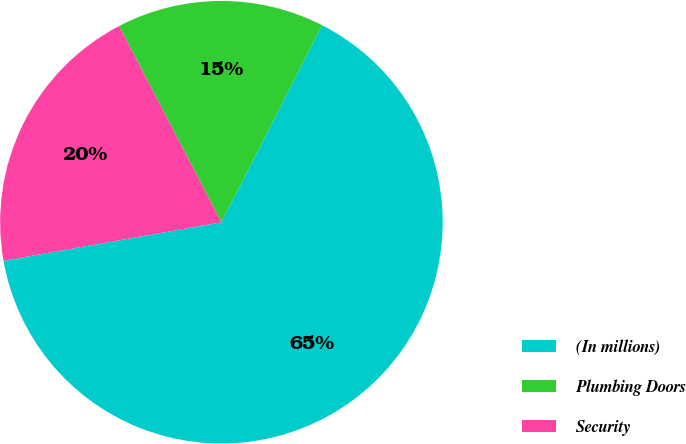Convert chart to OTSL. <chart><loc_0><loc_0><loc_500><loc_500><pie_chart><fcel>(In millions)<fcel>Plumbing Doors<fcel>Security<nl><fcel>64.69%<fcel>15.18%<fcel>20.13%<nl></chart> 